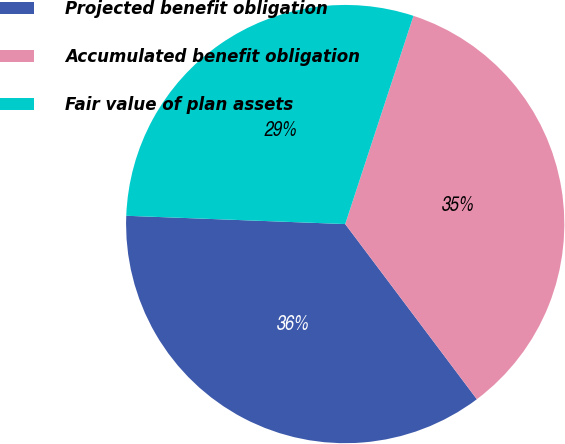Convert chart. <chart><loc_0><loc_0><loc_500><loc_500><pie_chart><fcel>Projected benefit obligation<fcel>Accumulated benefit obligation<fcel>Fair value of plan assets<nl><fcel>35.86%<fcel>34.7%<fcel>29.44%<nl></chart> 